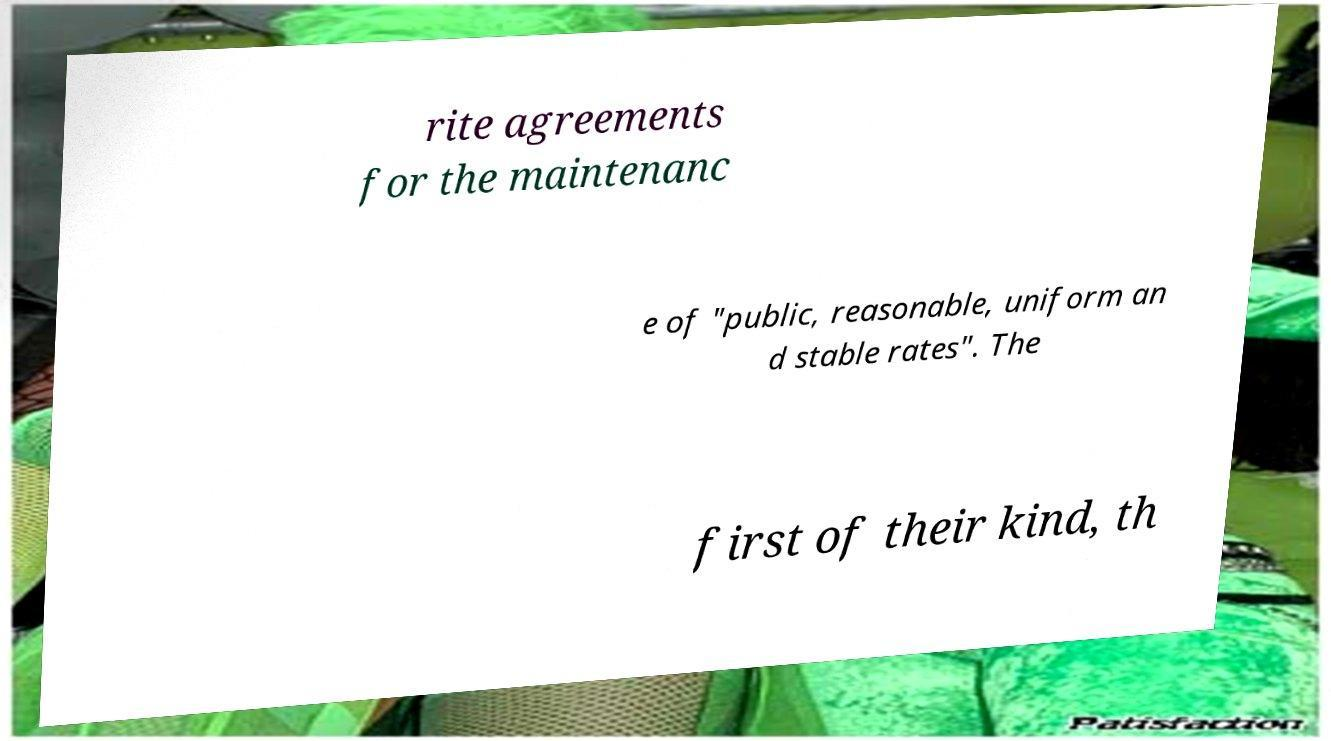Please identify and transcribe the text found in this image. rite agreements for the maintenanc e of "public, reasonable, uniform an d stable rates". The first of their kind, th 